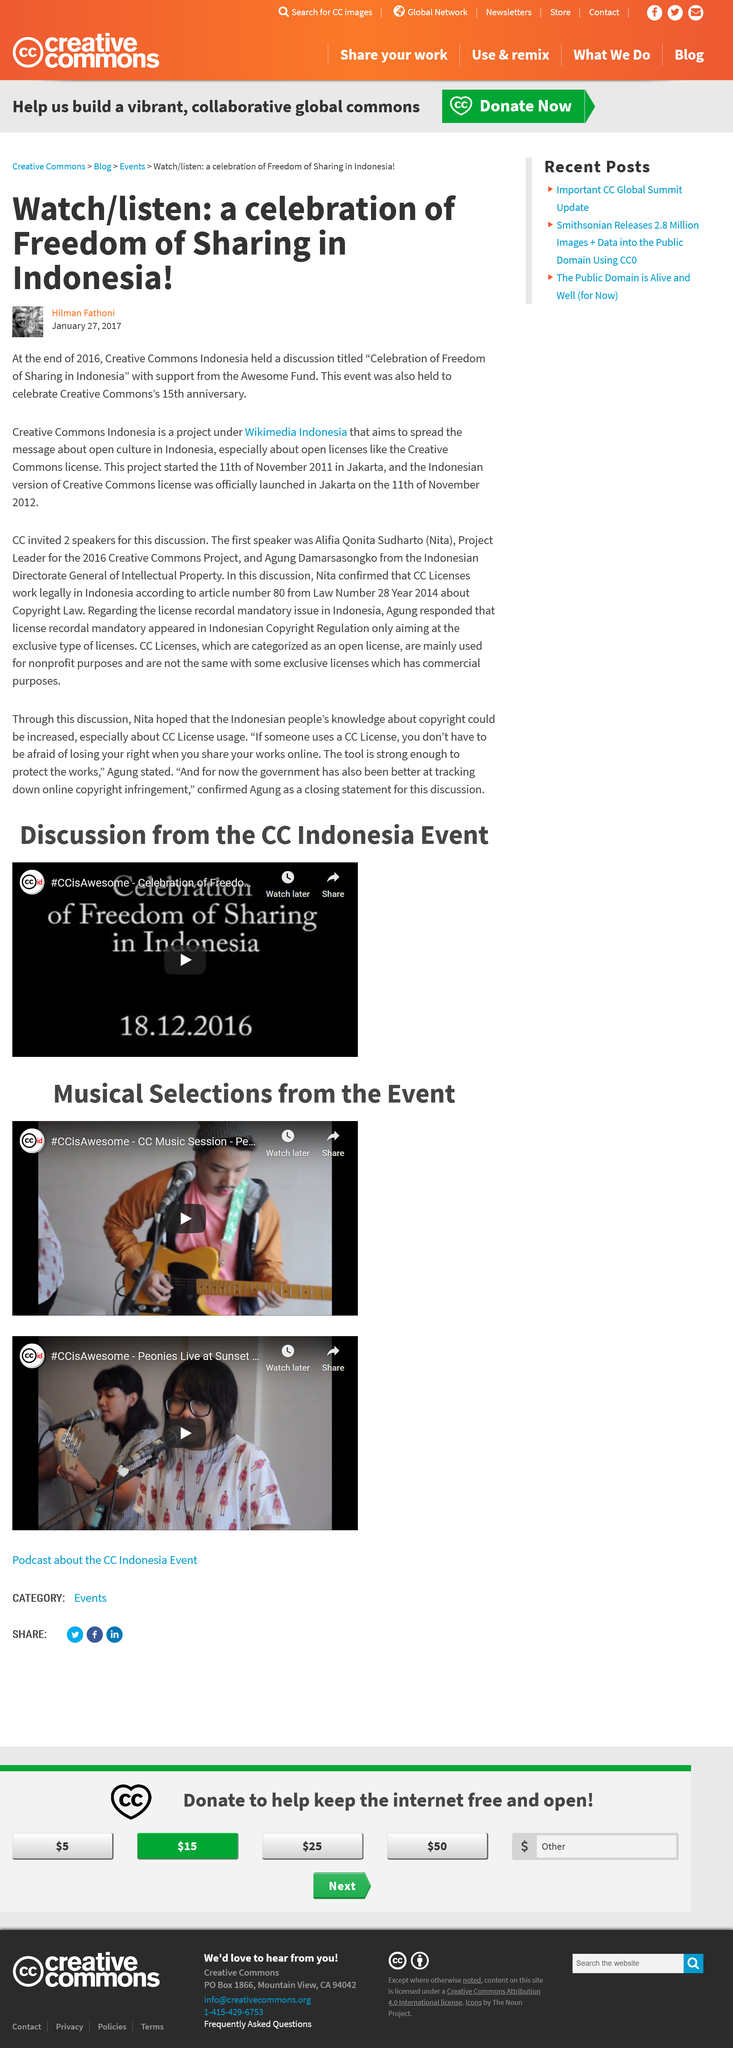Highlight a few significant elements in this photo. The article was published on 27 January 2017. Creative Commons celebrated its 15th anniversary. The celebration in Indonesia was a declaration of freedom of sharing. 